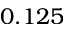<formula> <loc_0><loc_0><loc_500><loc_500>0 . 1 2 5</formula> 